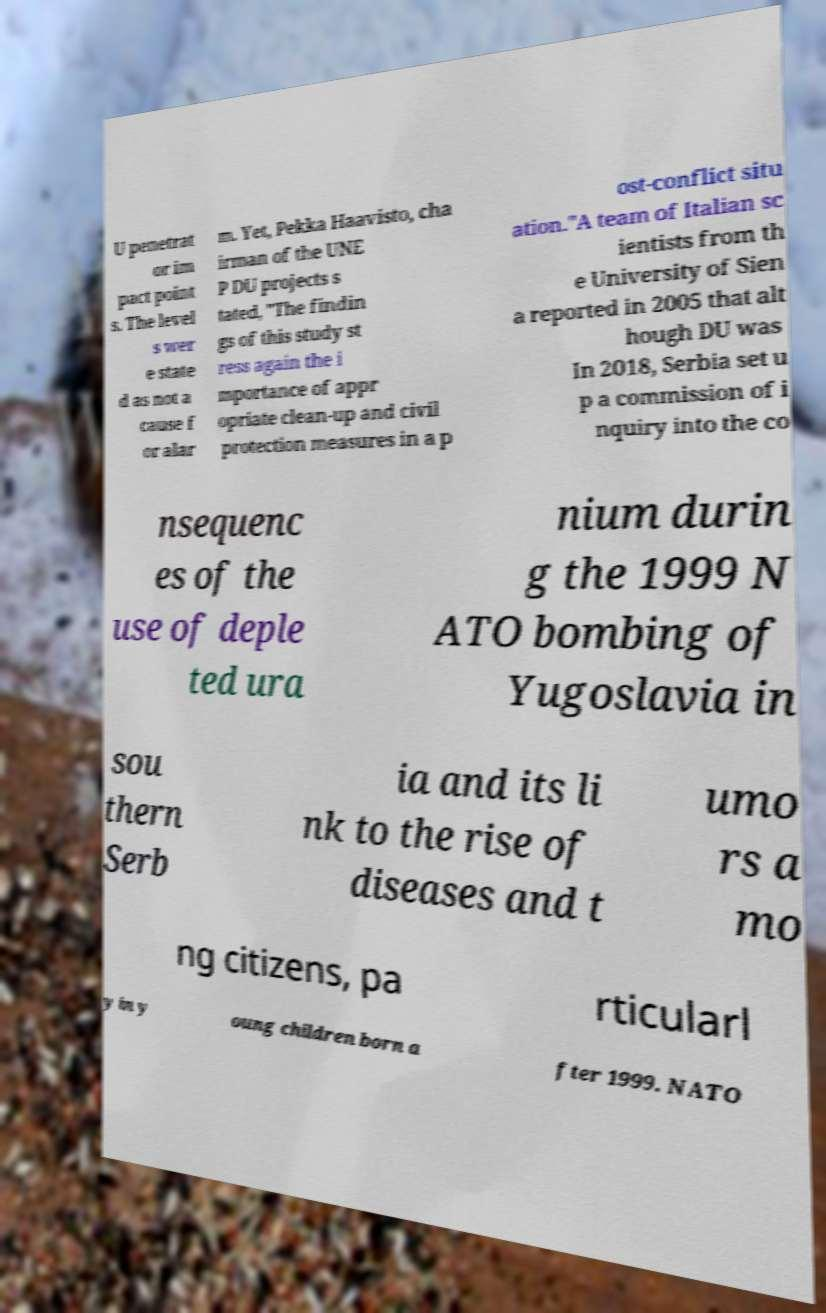I need the written content from this picture converted into text. Can you do that? U penetrat or im pact point s. The level s wer e state d as not a cause f or alar m. Yet, Pekka Haavisto, cha irman of the UNE P DU projects s tated, "The findin gs of this study st ress again the i mportance of appr opriate clean-up and civil protection measures in a p ost-conflict situ ation."A team of Italian sc ientists from th e University of Sien a reported in 2005 that alt hough DU was In 2018, Serbia set u p a commission of i nquiry into the co nsequenc es of the use of deple ted ura nium durin g the 1999 N ATO bombing of Yugoslavia in sou thern Serb ia and its li nk to the rise of diseases and t umo rs a mo ng citizens, pa rticularl y in y oung children born a fter 1999. NATO 